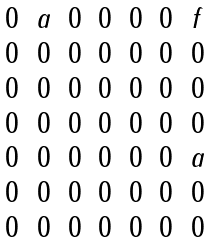<formula> <loc_0><loc_0><loc_500><loc_500>\begin{matrix} 0 & a & 0 & 0 & 0 & 0 & f \\ 0 & 0 & 0 & 0 & 0 & 0 & 0 \\ 0 & 0 & 0 & 0 & 0 & 0 & 0 \\ 0 & 0 & 0 & 0 & 0 & 0 & 0 \\ 0 & 0 & 0 & 0 & 0 & 0 & a \\ 0 & 0 & 0 & 0 & 0 & 0 & 0 \\ 0 & 0 & 0 & 0 & 0 & 0 & 0 \\ \end{matrix}</formula> 